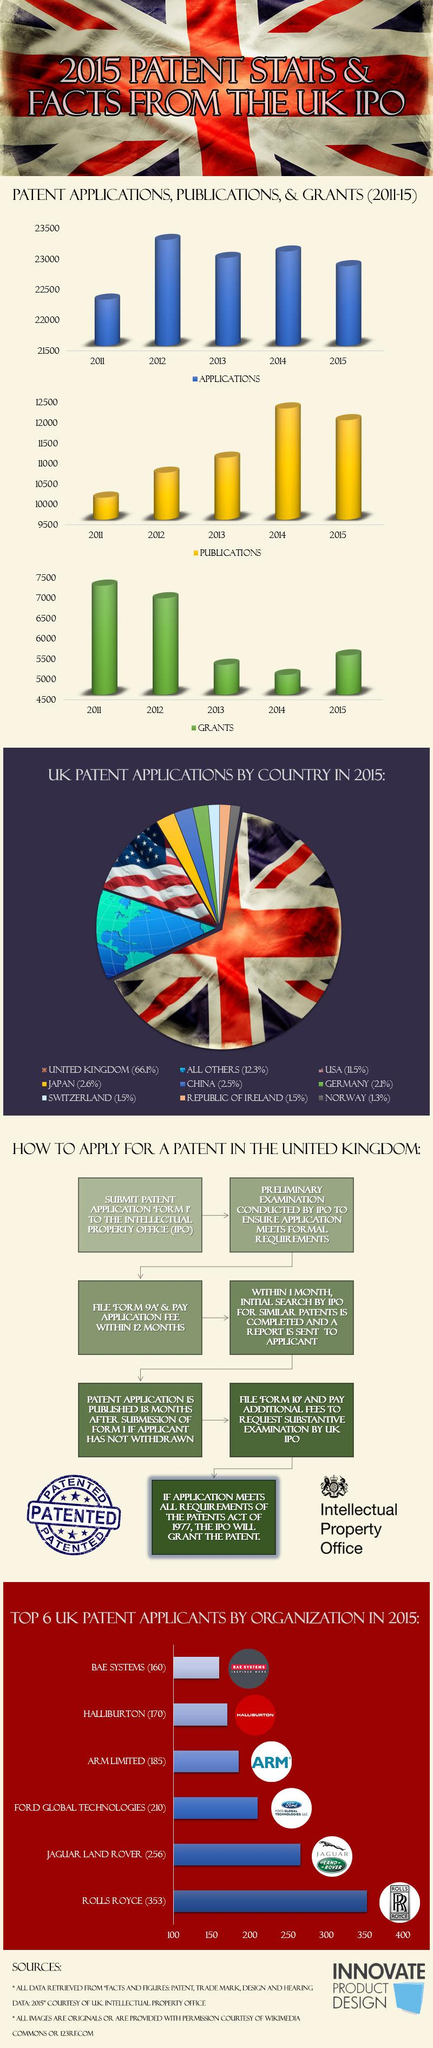Point out several critical features in this image. The third step in the process of applying for a patent in the United Kingdom is to file "form 9A" and pay the application fee within 12 months. 